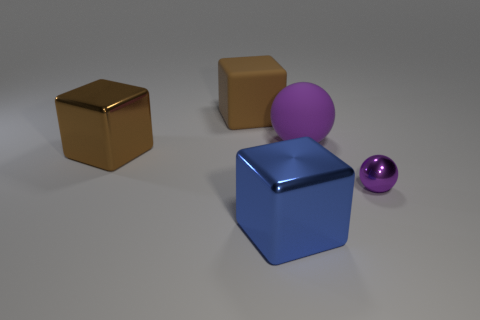Add 2 big brown cubes. How many objects exist? 7 Subtract all balls. How many objects are left? 3 Add 4 small gray cubes. How many small gray cubes exist? 4 Subtract 2 brown cubes. How many objects are left? 3 Subtract all purple shiny cubes. Subtract all matte cubes. How many objects are left? 4 Add 3 purple rubber objects. How many purple rubber objects are left? 4 